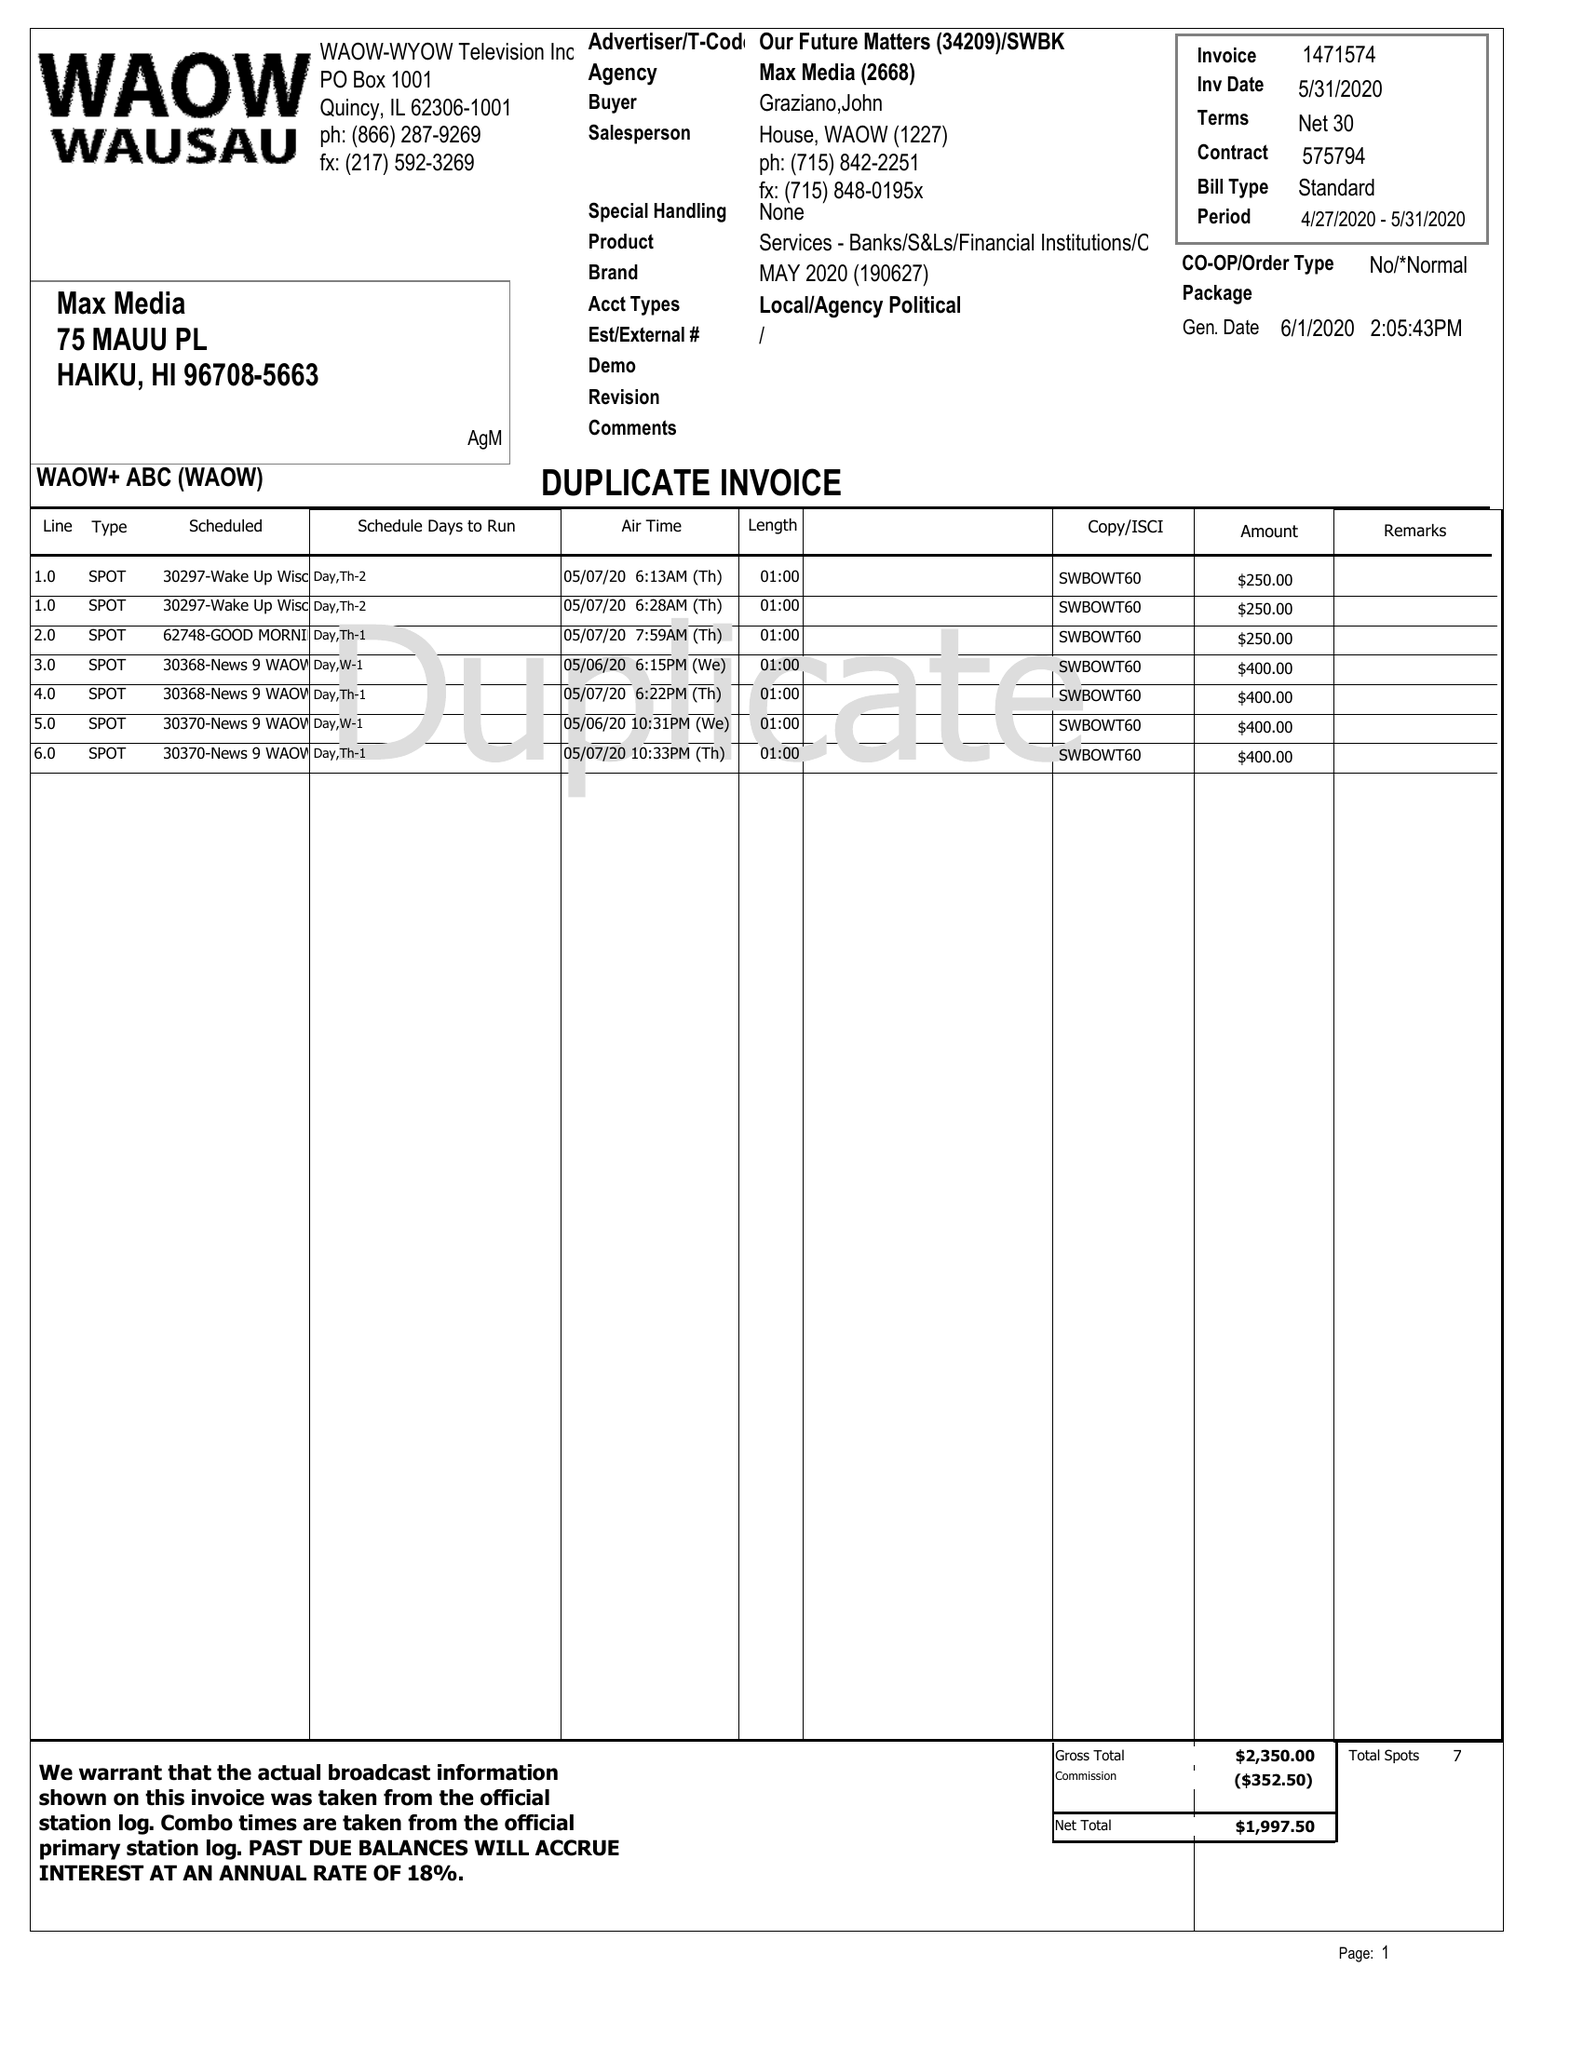What is the value for the flight_from?
Answer the question using a single word or phrase. 04/27/20 